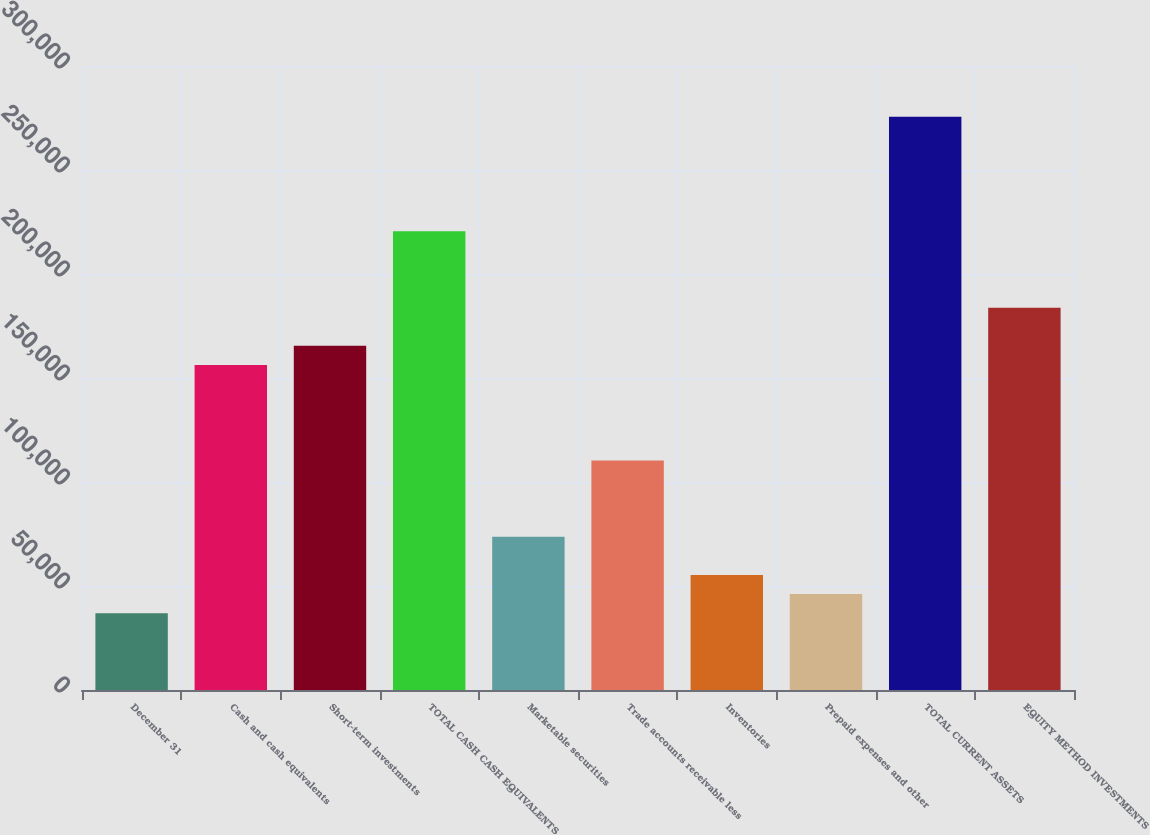Convert chart to OTSL. <chart><loc_0><loc_0><loc_500><loc_500><bar_chart><fcel>December 31<fcel>Cash and cash equivalents<fcel>Short-term investments<fcel>TOTAL CASH CASH EQUIVALENTS<fcel>Marketable securities<fcel>Trade accounts receivable less<fcel>Inventories<fcel>Prepaid expenses and other<fcel>TOTAL CURRENT ASSETS<fcel>EQUITY METHOD INVESTMENTS<nl><fcel>36953.8<fcel>156270<fcel>165449<fcel>220518<fcel>73666.6<fcel>110379<fcel>55310.2<fcel>46132<fcel>275587<fcel>183805<nl></chart> 